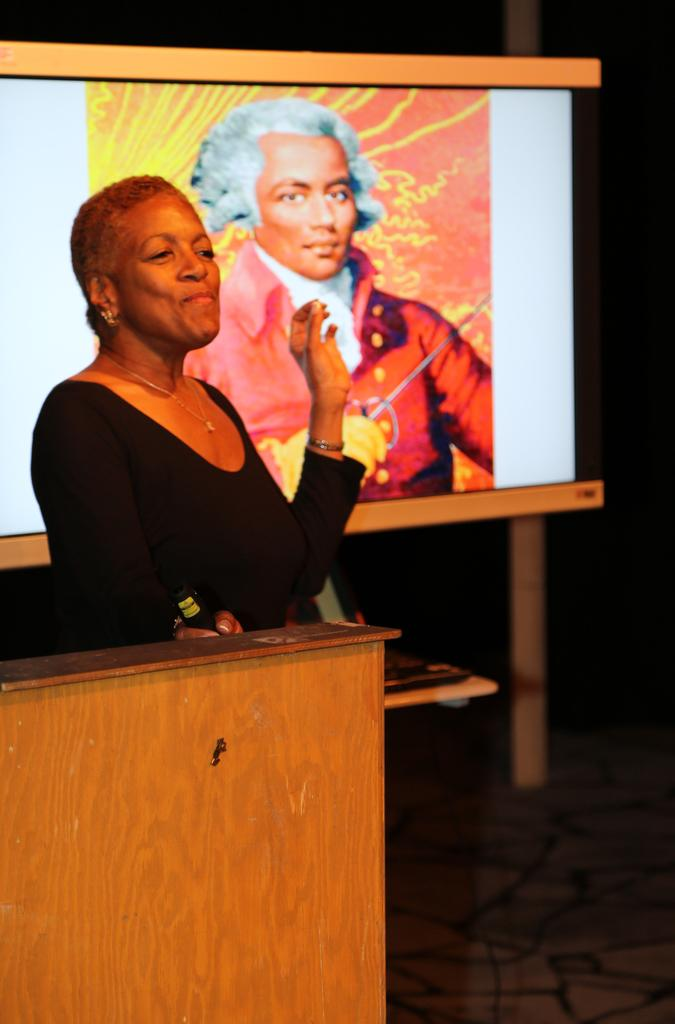What is the woman in the image doing? The woman is standing in the image and smiling. What can be seen behind the woman in the image? There appears to be a wooden podium in the image. What is displayed on the screen in the image? There is a screen displaying a picture in the image. What type of credit card does the woman have in her hand in the image? There is no credit card visible in the woman's hand in the image. How many trains can be seen passing by in the background of the image? There are no trains present in the image. 